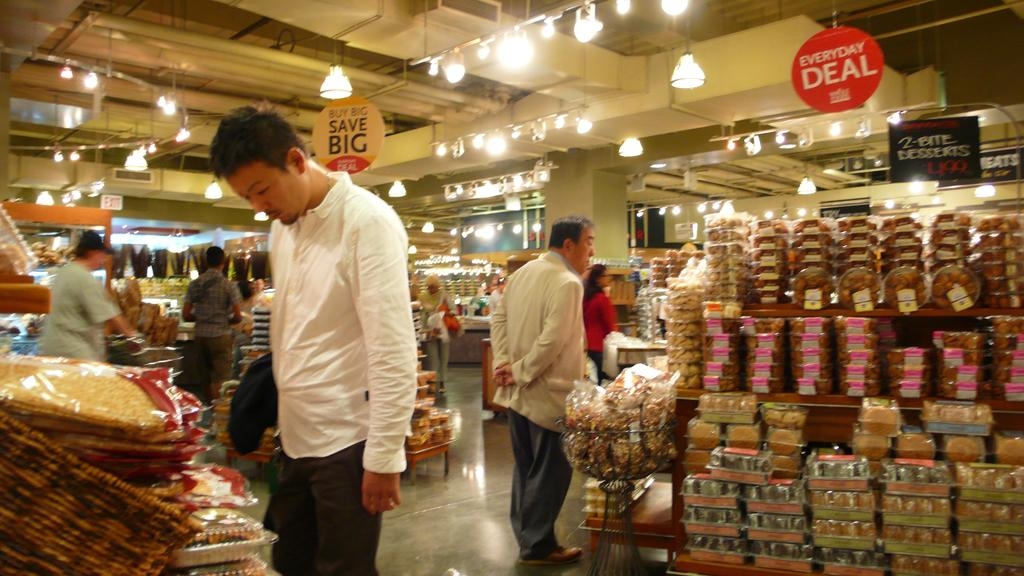<image>
Describe the image concisely. Bakery section of grocery store with signs hanging saying Save Big and everyday deal. 